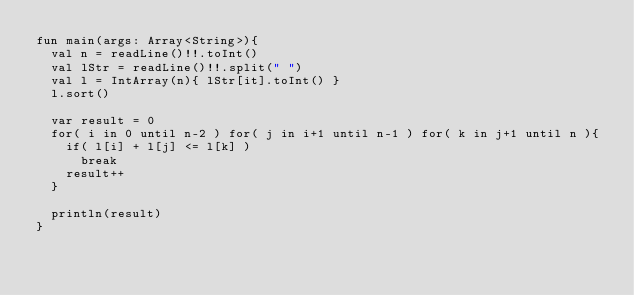Convert code to text. <code><loc_0><loc_0><loc_500><loc_500><_Kotlin_>fun main(args: Array<String>){
  val n = readLine()!!.toInt()
  val lStr = readLine()!!.split(" ")
  val l = IntArray(n){ lStr[it].toInt() }
  l.sort()

  var result = 0
  for( i in 0 until n-2 ) for( j in i+1 until n-1 ) for( k in j+1 until n ){
    if( l[i] + l[j] <= l[k] )
      break
    result++
  }

  println(result)
}
</code> 